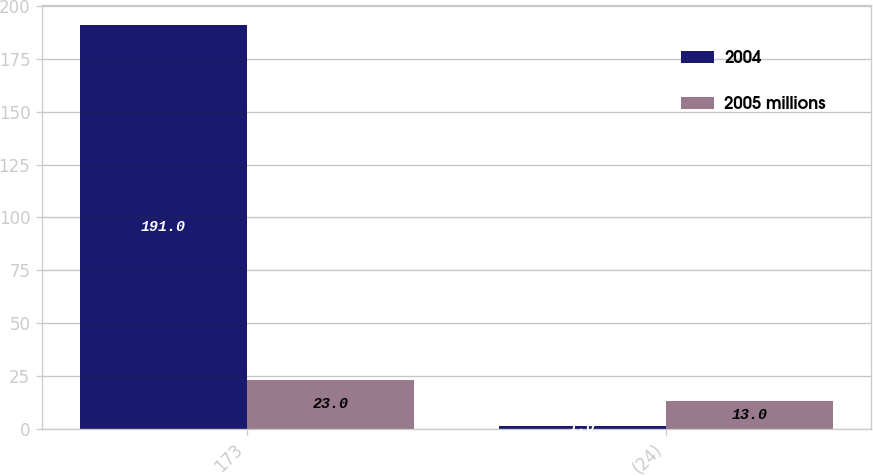Convert chart to OTSL. <chart><loc_0><loc_0><loc_500><loc_500><stacked_bar_chart><ecel><fcel>173<fcel>(24)<nl><fcel>2004<fcel>191<fcel>1<nl><fcel>2005 millions<fcel>23<fcel>13<nl></chart> 